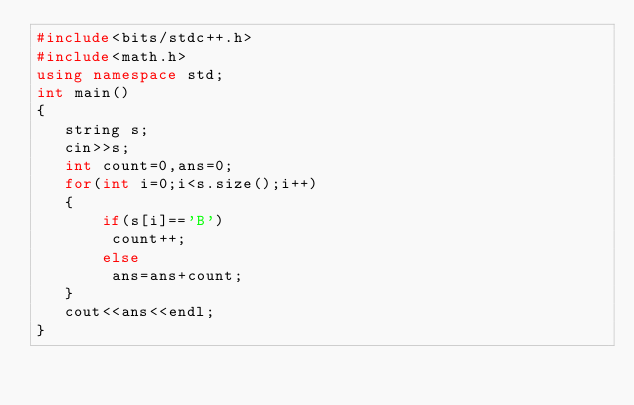Convert code to text. <code><loc_0><loc_0><loc_500><loc_500><_C++_>#include<bits/stdc++.h>
#include<math.h>
using namespace std;
int main()
{
   string s;
   cin>>s;
   int count=0,ans=0;
   for(int i=0;i<s.size();i++)
   {
       if(s[i]=='B')
        count++;
       else
        ans=ans+count;
   }
   cout<<ans<<endl;
}
</code> 